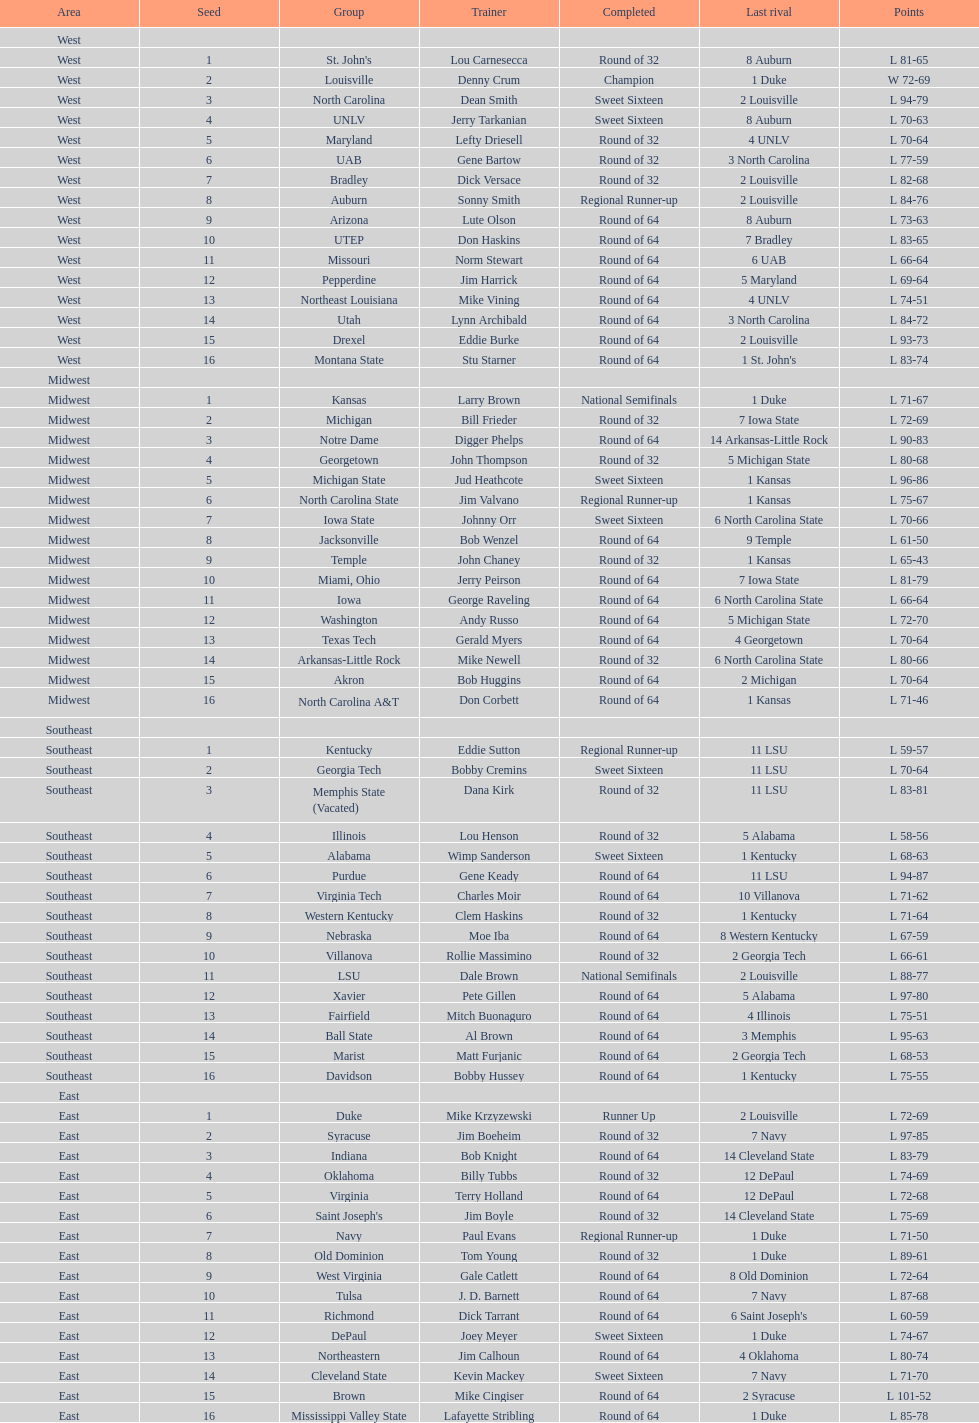Which team went finished later in the tournament, st. john's or north carolina a&t? North Carolina A&T. 